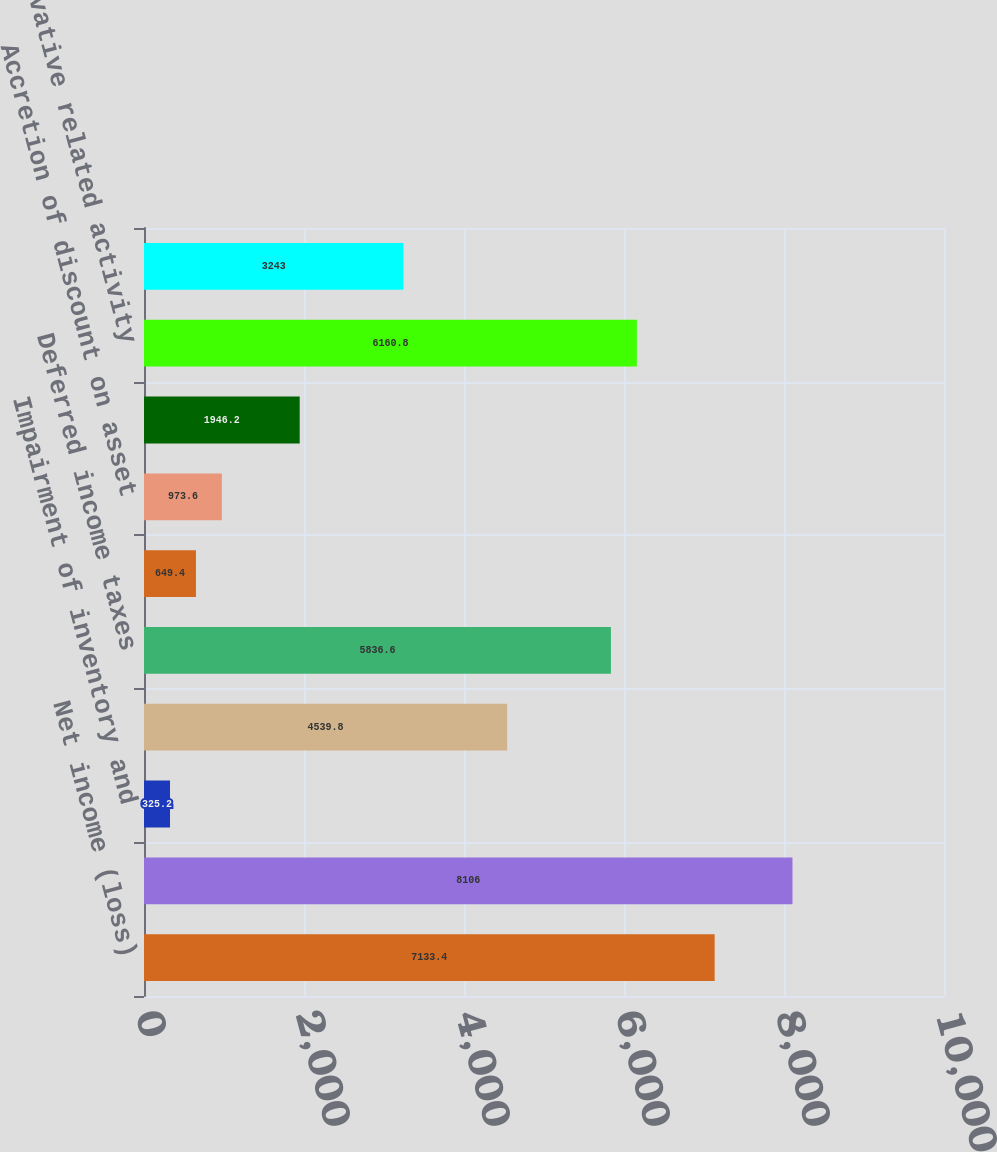<chart> <loc_0><loc_0><loc_500><loc_500><bar_chart><fcel>Net income (loss)<fcel>Depletion depreciation and<fcel>Impairment of inventory and<fcel>Exploration expenses including<fcel>Deferred income taxes<fcel>Gain on disposition of assets<fcel>Accretion of discount on asset<fcel>Interest expense<fcel>Derivative related activity<fcel>Accounts receivable<nl><fcel>7133.4<fcel>8106<fcel>325.2<fcel>4539.8<fcel>5836.6<fcel>649.4<fcel>973.6<fcel>1946.2<fcel>6160.8<fcel>3243<nl></chart> 